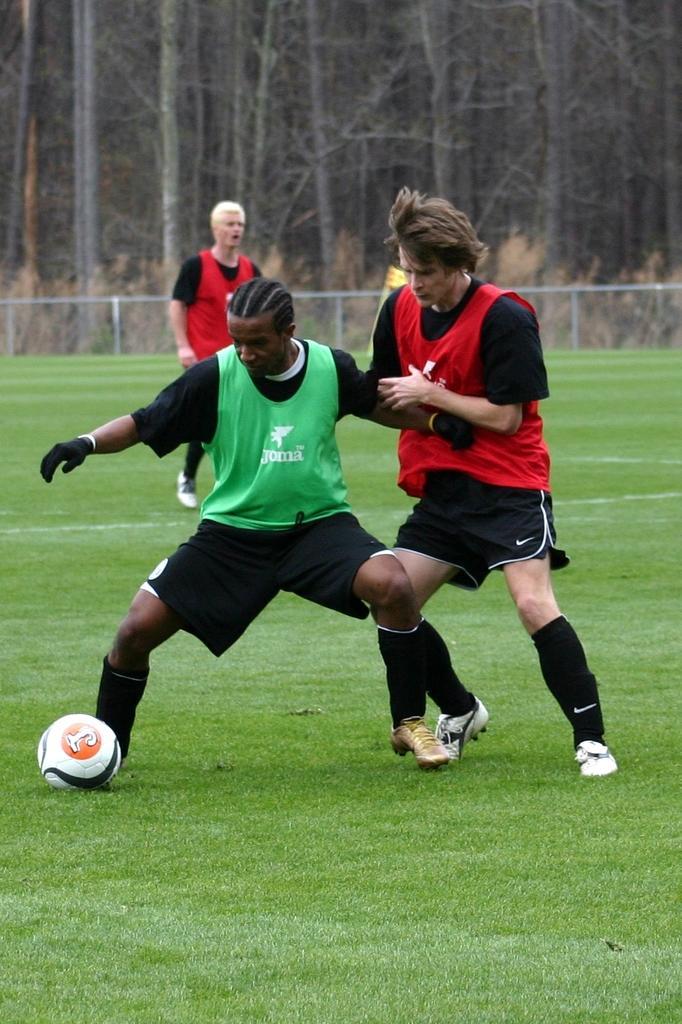Could you give a brief overview of what you see in this image? In the foreground of this image, there are two men playing football. In the background, there is a man walking on the grass, fencing and the trees. 